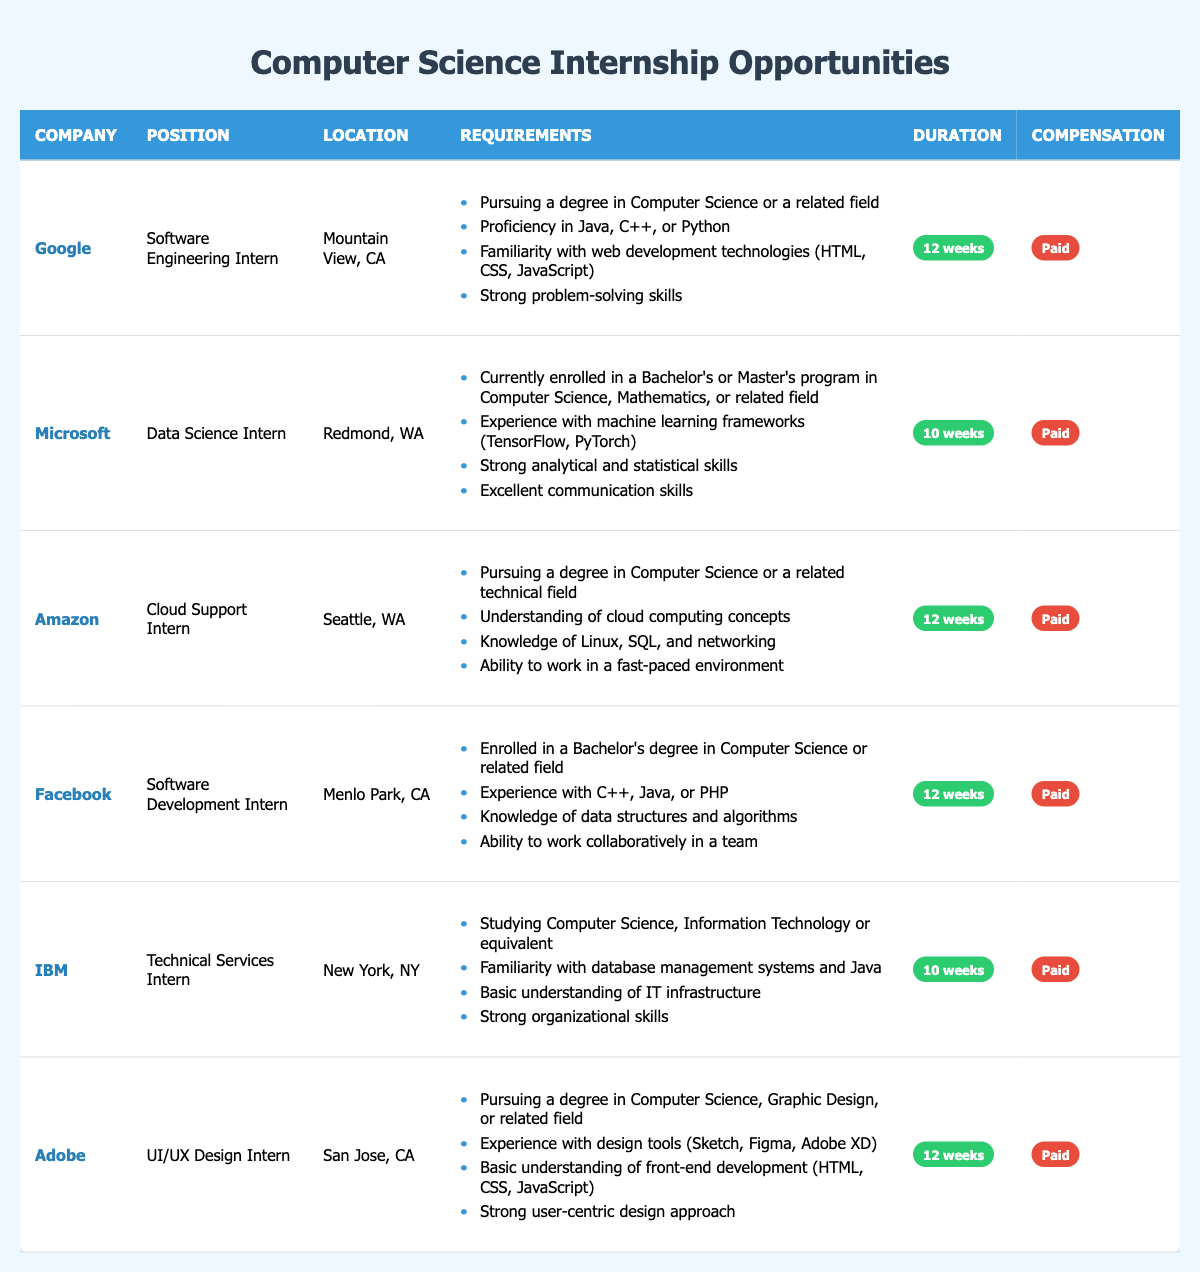What are the requirements for the Software Engineering Intern position at Google? According to the table, the requirements for the Software Engineering Intern position at Google include: pursuing a degree in Computer Science or a related field, proficiency in Java, C++, or Python, familiarity with web development technologies (HTML, CSS, JavaScript), and strong problem-solving skills.
Answer: Pursuing a degree in Computer Science or a related field, proficiency in Java, C++, or Python, familiarity with web development technologies, strong problem-solving skills How many weeks is the Data Science Internship at Microsoft? From the table, the duration for the Data Science Internship at Microsoft is specified as 10 weeks.
Answer: 10 weeks Which companies offer internships for 12 weeks? By reviewing the table, the companies that offer internships for 12 weeks are Google, Amazon, Facebook, and Adobe.
Answer: Google, Amazon, Facebook, Adobe Is the internship at IBM paid? The table indicates that the Technical Services Intern position at IBM has compensation listed as "Paid," which means it is indeed a paid internship.
Answer: Yes What is the relationship between the required skills for the Cloud Support Intern position at Amazon and for the Software Development Intern at Facebook? The Cloud Support Intern position at Amazon requires knowledge in cloud computing concepts and Linux, SQL, and networking. The Software Development Intern at Facebook requires experience with programming languages like C++, Java, or PHP and knowledge of data structures and algorithms. There is overlap in skills concerning programming, but the Amazon role focuses on cloud computing.
Answer: They both require technical programming skills, though they focus on different areas How many internships are located in California? The table shows that there are three internships located in California: Google, Facebook, and Adobe. Therefore, counting these entries gives a total of three internships situated in California.
Answer: 3 What is the common requirement for all these internships regarding educational background? Upon examining the table, it is evident that all internships require candidates to be pursuing a degree in Computer Science or a related field, which highlights the standard educational prerequisite across these positions.
Answer: Pursuing a degree in Computer Science or a related field Which internship has the longest duration and how long is it? To find the internship with the longest duration, we look at the durations listed in the table. The internships at Google, Amazon, Facebook, and Adobe are all for 12 weeks, which is the longest duration listed.
Answer: 12 weeks (offered by Google, Amazon, Facebook, Adobe) 